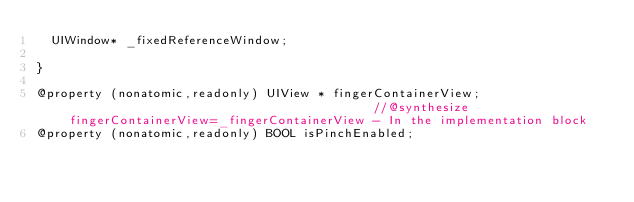<code> <loc_0><loc_0><loc_500><loc_500><_C_>	UIWindow* _fixedReferenceWindow;

}

@property (nonatomic,readonly) UIView * fingerContainerView;                                          //@synthesize fingerContainerView=_fingerContainerView - In the implementation block
@property (nonatomic,readonly) BOOL isPinchEnabled; </code> 